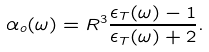<formula> <loc_0><loc_0><loc_500><loc_500>\alpha _ { o } ( \omega ) = R ^ { 3 } \frac { \epsilon _ { T } ( \omega ) - 1 } { \epsilon _ { T } ( \omega ) + 2 } .</formula> 